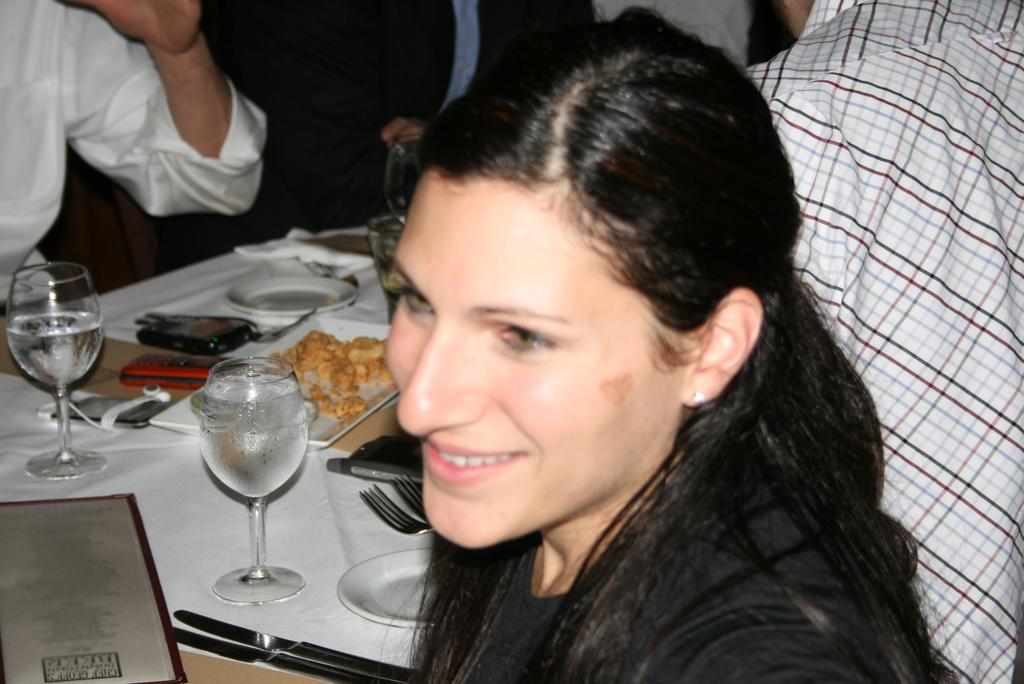What is the woman in the image wearing? The woman is wearing a black dress. What is the woman's facial expression in the image? The woman is smiling. Where is the woman sitting in the image? The woman is sitting in front of a table. What can be seen on the table in the image? There are wine glasses, food, plates, forks, a book, and a cloth on the table. Who is present at the table in the image? There are people on either side of the table. What type of farming equipment is visible in the image? There is no farming equipment present in the image. What does the woman need to complete her task in the image? The image does not depict a task that requires any specific item or action, so it is not possible to determine what the woman might need. 